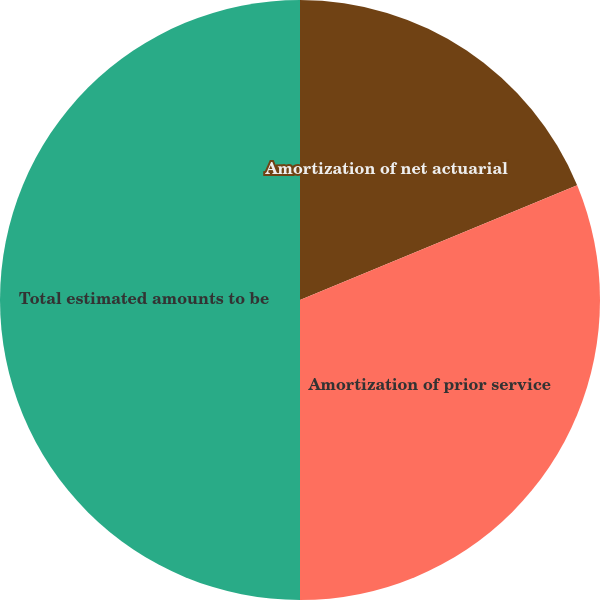<chart> <loc_0><loc_0><loc_500><loc_500><pie_chart><fcel>Amortization of net actuarial<fcel>Amortization of prior service<fcel>Total estimated amounts to be<nl><fcel>18.75%<fcel>31.25%<fcel>50.0%<nl></chart> 